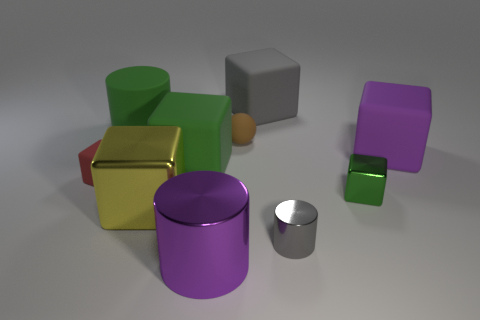Subtract 1 blocks. How many blocks are left? 5 Subtract all gray cubes. How many cubes are left? 5 Subtract all tiny shiny blocks. How many blocks are left? 5 Subtract all blue cubes. Subtract all cyan cylinders. How many cubes are left? 6 Subtract all balls. How many objects are left? 9 Add 8 tiny gray metallic cylinders. How many tiny gray metallic cylinders are left? 9 Add 1 small green blocks. How many small green blocks exist? 2 Subtract 0 cyan cylinders. How many objects are left? 10 Subtract all tiny green blocks. Subtract all gray metal things. How many objects are left? 8 